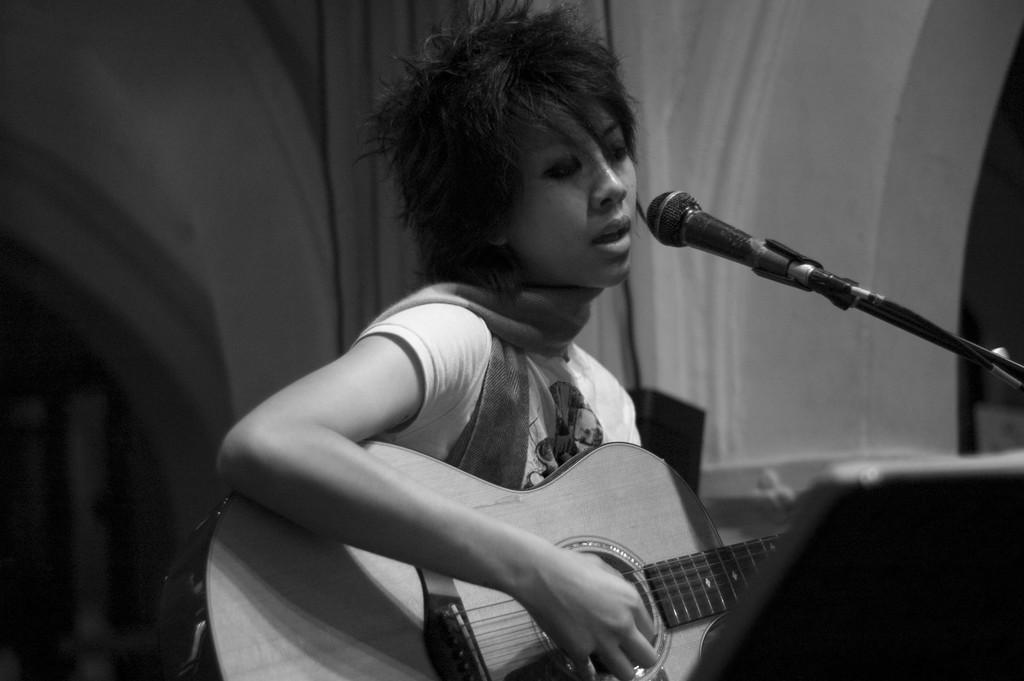What is the main subject of the image? There is a person in the image. What is the person doing in the image? The person is standing and playing a guitar. What object is in front of the person? There is a mic in front of the person. What type of winter clothing is the person wearing in the image? There is no mention of winter clothing or any specific season in the image, so it cannot be determined from the image. 